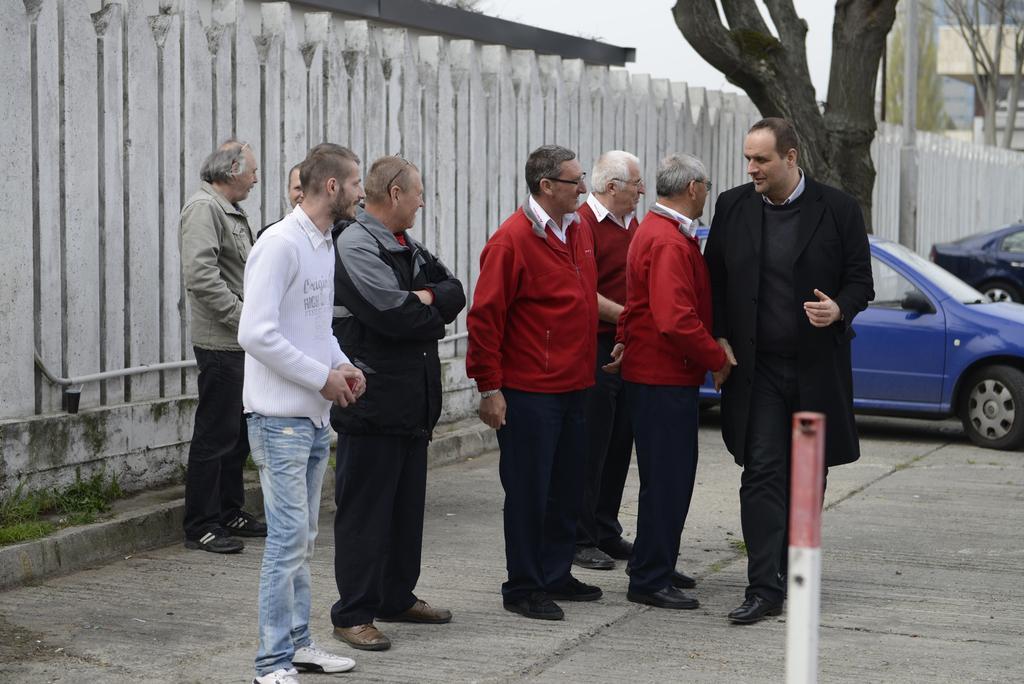How would you summarize this image in a sentence or two? Group of people standing and we can see pole. On the background we can see cars,wall,trees,pole and sky. 